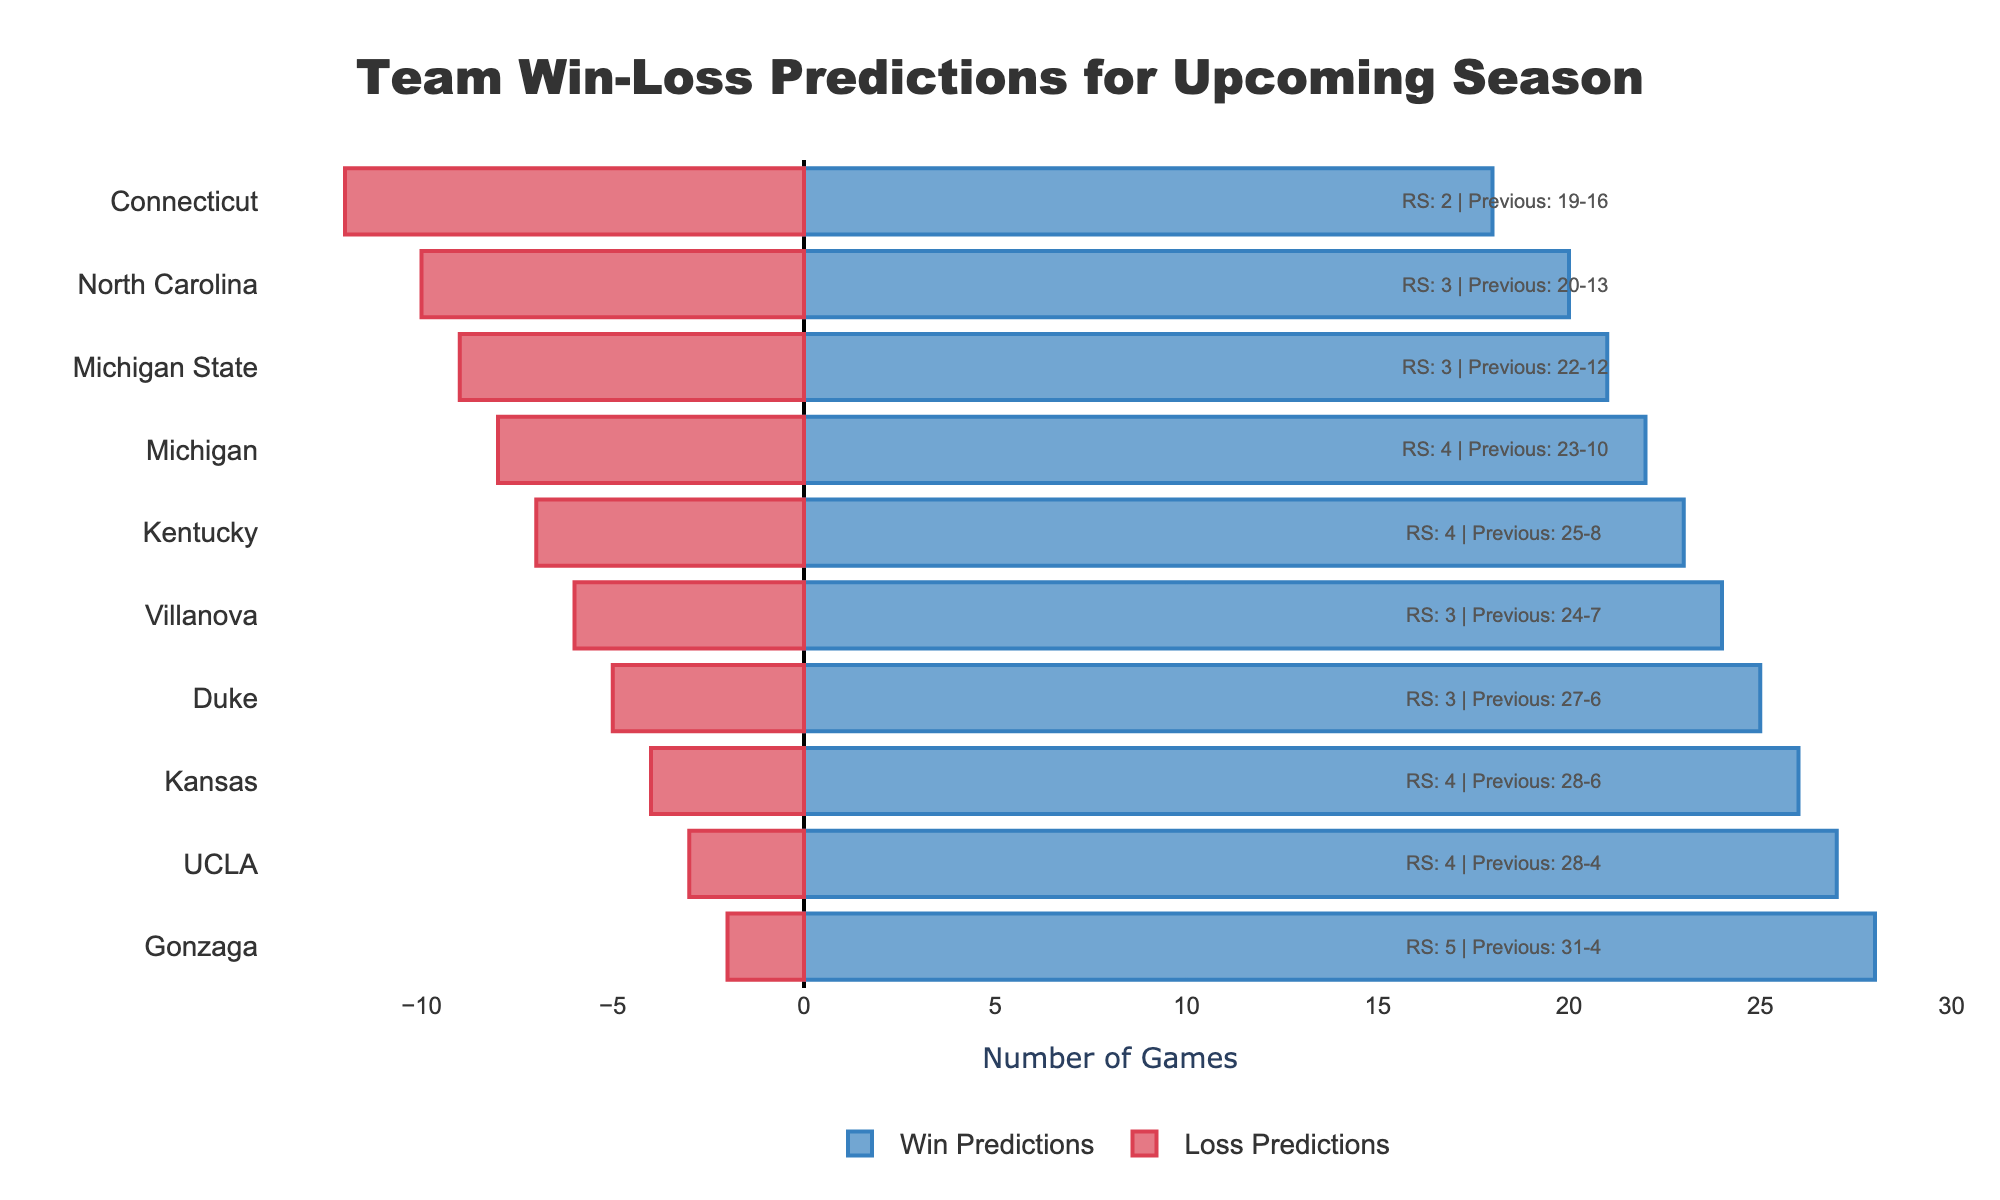Which team has the highest number of win predictions? To determine the highest number of win predictions, check the length of the blue bars on the right side of the chart. Gonzaga has the longest blue bar with 28 predicted wins.
Answer: Gonzaga Which two teams have equal win predictions? Look for teams with blue bars of the same length. Villanova and Kansas both have bars representing 24 win predictions each.
Answer: Villanova and Kansas What is the difference in loss predictions between Michigan and North Carolina? Compare the lengths of the red bars for Michigan and North Carolina. North Carolina has a bar of length 10, and Michigan's bar length is 8. The difference is 10 - 8 = 2.
Answer: 2 How many teams have more than 3 returning starters? Observe the annotations for Returning Starters and count the teams with numbers greater than 3. The teams are Kentucky, Kansas, Michigan, and UCLA.
Answer: 4 What are the total predicted losses for Connecticut and Michigan State combined? Sum the lengths of the red bars for Connecticut and Michigan State. Connecticut has 12 predicted losses, and Michigan State has 9. The total is 12 + 9 = 21.
Answer: 21 Which team has the lowest number of returning starters? Look at the annotations indicating Returning Starters. Connecticut has the lowest number with 2 returning starters.
Answer: Connecticut What is the sum of win predictions for Duke and Kansas? Add the values from the blue bars for Duke and Kansas. Duke has 25 predicted wins, and Kansas has 26. The sum is 25 + 26 = 51.
Answer: 51 Between Villanova and Michigan State, which team has a better previous season performance? Compare the annotations indicating previous season records. Villanova's record is 24-7, while Michigan State's is 22-12. Villanova has a better record.
Answer: Villanova What is the combined number of returning starters for Duke, North Carolina, and UCLA? Sum the returning starters for these teams using their annotations. Duke has 3, North Carolina has 3, and UCLA has 4. The total is 3 + 3 + 4 = 10.
Answer: 10 Which team has the greatest difference between win predictions and loss predictions? Calculate the differences by subtracting the lengths of the red bars from the blue bars for each team. Gonzaga has the largest difference: 28 (wins) - 2 (losses) = 26.
Answer: Gonzaga 